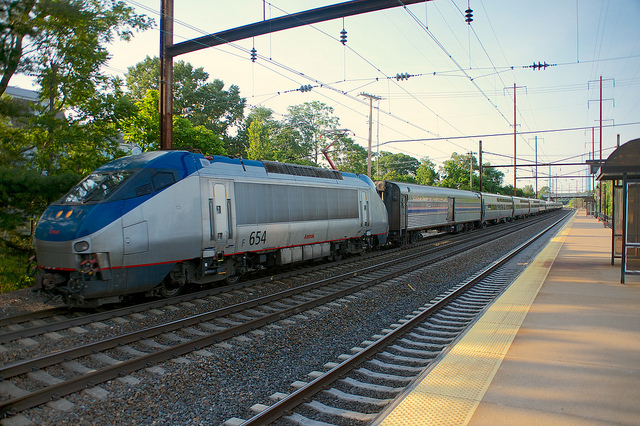Read and extract the text from this image. 654 